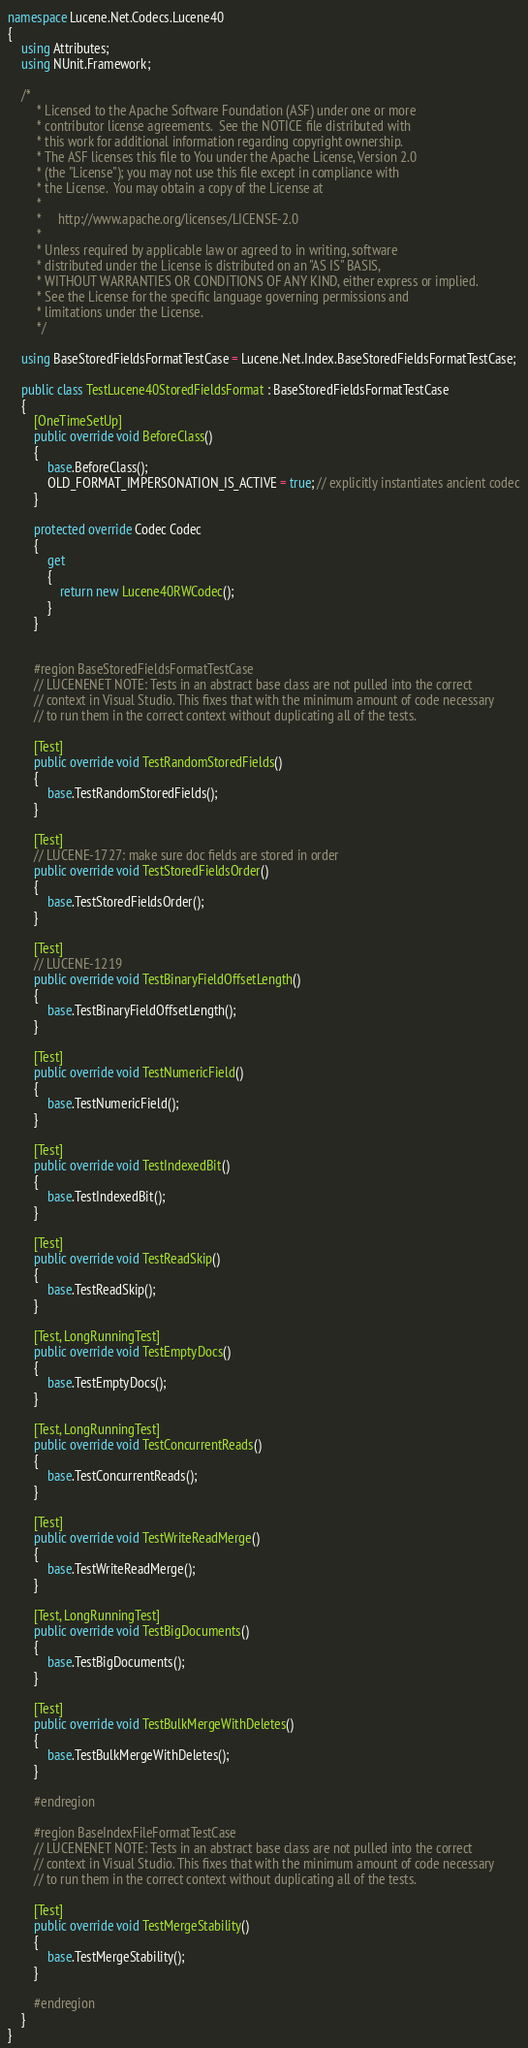Convert code to text. <code><loc_0><loc_0><loc_500><loc_500><_C#_>namespace Lucene.Net.Codecs.Lucene40
{
    using Attributes;
    using NUnit.Framework;

    /*
         * Licensed to the Apache Software Foundation (ASF) under one or more
         * contributor license agreements.  See the NOTICE file distributed with
         * this work for additional information regarding copyright ownership.
         * The ASF licenses this file to You under the Apache License, Version 2.0
         * (the "License"); you may not use this file except in compliance with
         * the License.  You may obtain a copy of the License at
         *
         *     http://www.apache.org/licenses/LICENSE-2.0
         *
         * Unless required by applicable law or agreed to in writing, software
         * distributed under the License is distributed on an "AS IS" BASIS,
         * WITHOUT WARRANTIES OR CONDITIONS OF ANY KIND, either express or implied.
         * See the License for the specific language governing permissions and
         * limitations under the License.
         */

    using BaseStoredFieldsFormatTestCase = Lucene.Net.Index.BaseStoredFieldsFormatTestCase;

    public class TestLucene40StoredFieldsFormat : BaseStoredFieldsFormatTestCase
    {
        [OneTimeSetUp]
        public override void BeforeClass()
        {
            base.BeforeClass();
            OLD_FORMAT_IMPERSONATION_IS_ACTIVE = true; // explicitly instantiates ancient codec
        }

        protected override Codec Codec
        {
            get
            {
                return new Lucene40RWCodec();
            }
        }


        #region BaseStoredFieldsFormatTestCase
        // LUCENENET NOTE: Tests in an abstract base class are not pulled into the correct
        // context in Visual Studio. This fixes that with the minimum amount of code necessary
        // to run them in the correct context without duplicating all of the tests.

        [Test]
        public override void TestRandomStoredFields()
        {
            base.TestRandomStoredFields();
        }

        [Test]
        // LUCENE-1727: make sure doc fields are stored in order
        public override void TestStoredFieldsOrder()
        {
            base.TestStoredFieldsOrder();
        }

        [Test]
        // LUCENE-1219
        public override void TestBinaryFieldOffsetLength()
        {
            base.TestBinaryFieldOffsetLength();
        }

        [Test]
        public override void TestNumericField()
        {
            base.TestNumericField();
        }

        [Test]
        public override void TestIndexedBit()
        {
            base.TestIndexedBit();
        }

        [Test]
        public override void TestReadSkip()
        {
            base.TestReadSkip();
        }

        [Test, LongRunningTest]
        public override void TestEmptyDocs()
        {
            base.TestEmptyDocs();
        }

        [Test, LongRunningTest]
        public override void TestConcurrentReads()
        {
            base.TestConcurrentReads();
        }

        [Test]
        public override void TestWriteReadMerge()
        {
            base.TestWriteReadMerge();
        }

        [Test, LongRunningTest]
        public override void TestBigDocuments()
        {
            base.TestBigDocuments();
        }

        [Test]
        public override void TestBulkMergeWithDeletes()
        {
            base.TestBulkMergeWithDeletes();
        }

        #endregion

        #region BaseIndexFileFormatTestCase
        // LUCENENET NOTE: Tests in an abstract base class are not pulled into the correct
        // context in Visual Studio. This fixes that with the minimum amount of code necessary
        // to run them in the correct context without duplicating all of the tests.

        [Test]
        public override void TestMergeStability()
        {
            base.TestMergeStability();
        }

        #endregion
    }
}</code> 